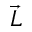<formula> <loc_0><loc_0><loc_500><loc_500>\vec { L }</formula> 